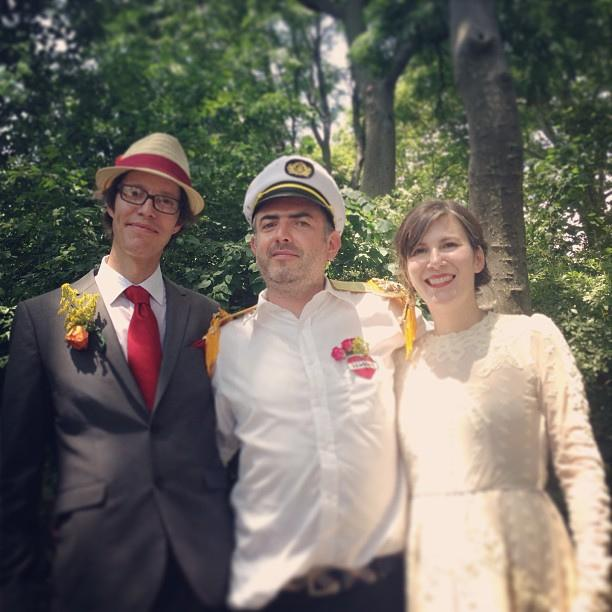What type of hat does the man in white have on? Please explain your reasoning. captains. The man is wearing a sailor hat. 